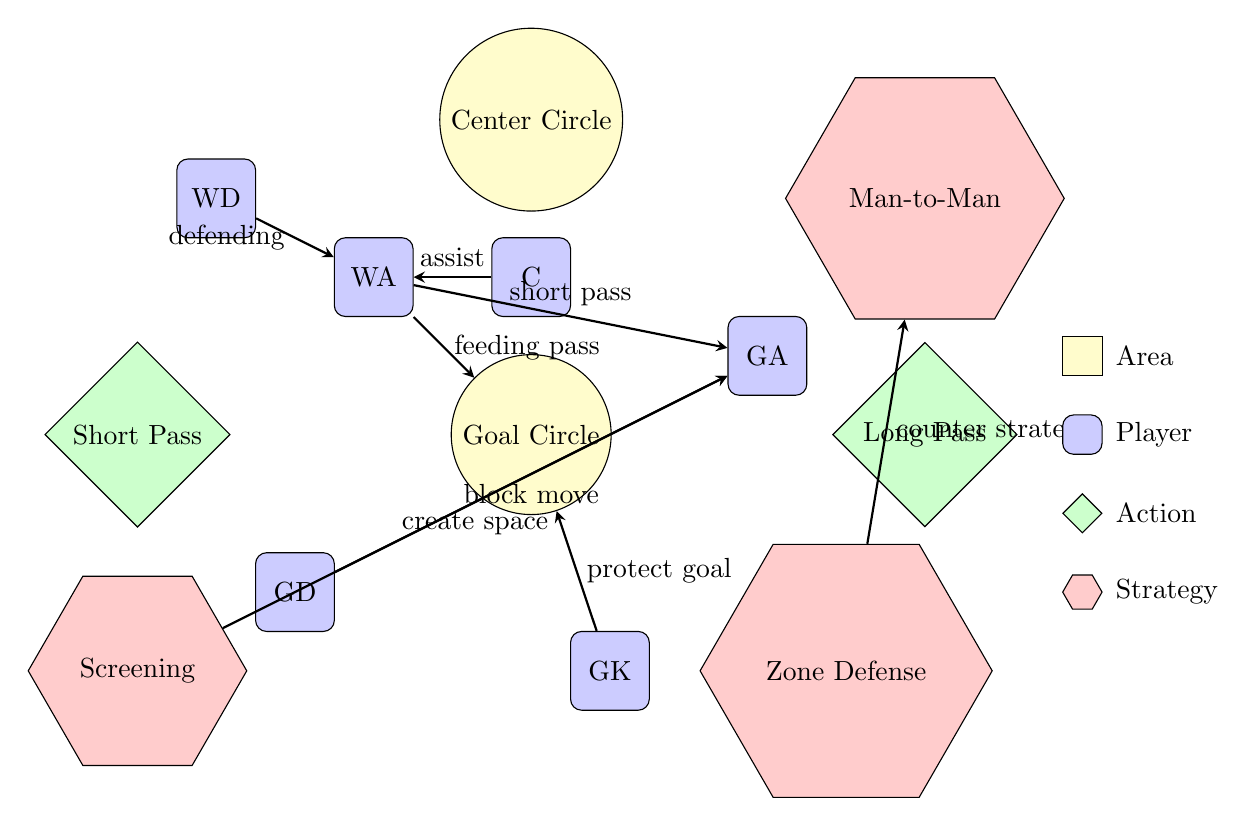What is the area designated for scoring? The diagram shows a circular area labeled "Goal Circle." This indicates that this is the area where scoring occurs during the game.
Answer: Goal Circle Which player is positioned at the top center of the diagram? The player at the top center of the diagram is labeled "C," which stands for Center. This indicates their position on the court.
Answer: C What action can WA perform to pass the ball to GA? The arrow labeled "short pass" connects WA to GA, indicating that WA can perform a short pass to get the ball to GA.
Answer: Short Pass How many players are represented in the diagram? By counting the labeled player nodes (GD, GK, GA, WA, C, and WD) in the diagram, there are a total of six players represented.
Answer: 6 What strategy is suggested by the arrow pointing from Screening? The arrow from Screening directs toward GA, indicating that Screening is used to create space for GA on the court, facilitating their movements or actions.
Answer: Create Space What defensive strategy is represented in the diagram? The diagram includes "Zone Defense" and "Man-to-Man" as potential strategies for defense, showing different techniques defenders can use during gameplay.
Answer: Zone Defense, Man-to-Man Which player is responsible for protecting the goal? The player labeled "GK" (Goalkeeper) is positioned closest to the Goal Circle, indicating this player has the responsibility for protecting the goal area during the game.
Answer: GK What is the connection between WA and the Goal Circle? The arrow indicates that WA can perform a "feeding pass," which is an action directed towards the Goal Circle, showing WA's role in facilitating passing to score.
Answer: Feeding Pass In total, how many actions are depicted in the diagram? There are two action nodes shown in the diagram: "Short Pass" and "Long Pass," indicating that these are the two primary actions represented.
Answer: 2 